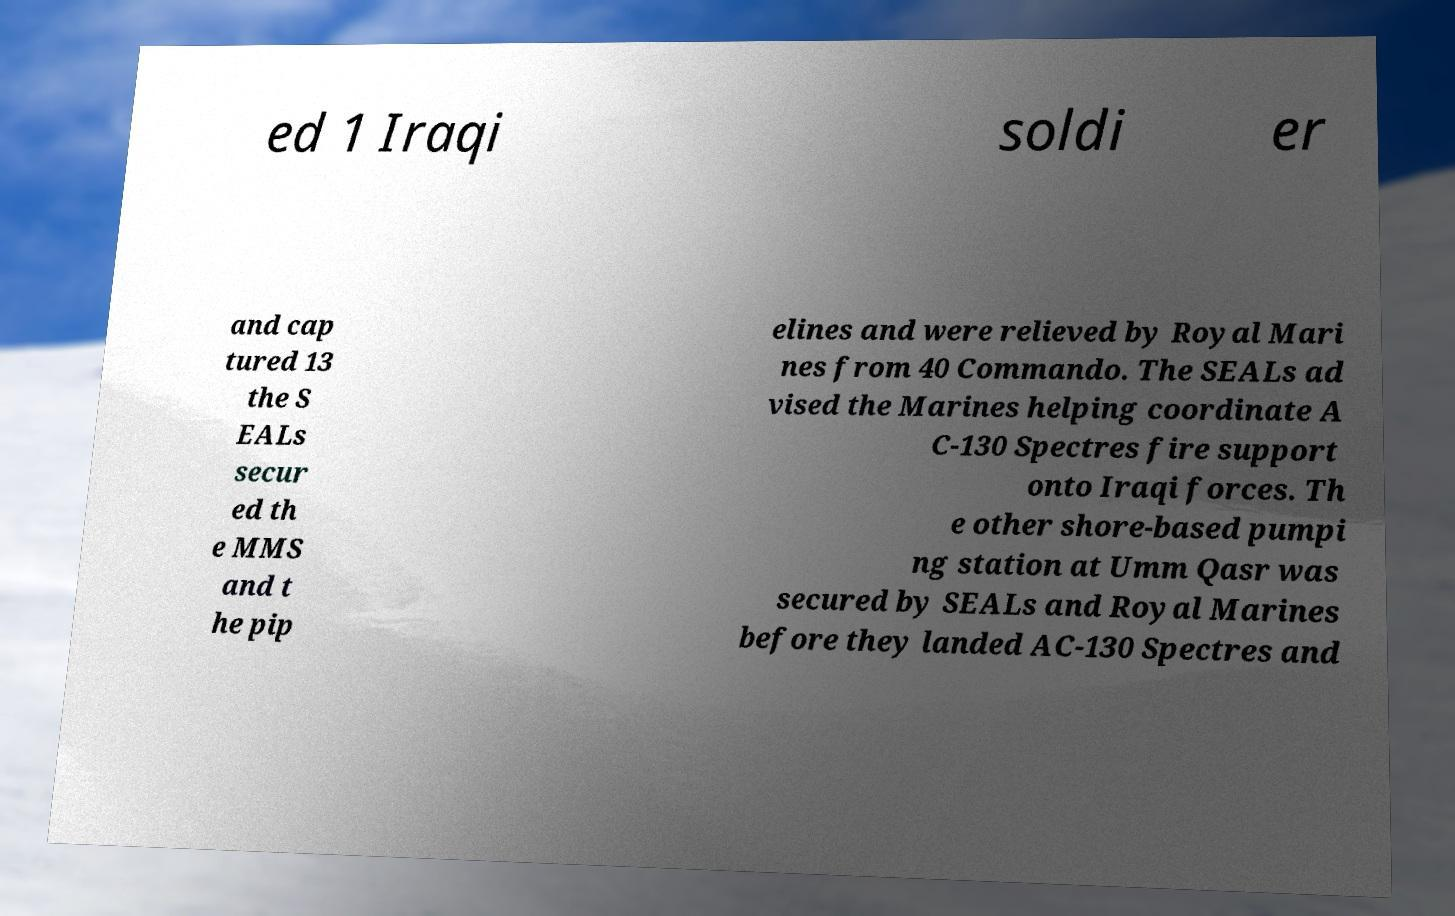Please read and relay the text visible in this image. What does it say? ed 1 Iraqi soldi er and cap tured 13 the S EALs secur ed th e MMS and t he pip elines and were relieved by Royal Mari nes from 40 Commando. The SEALs ad vised the Marines helping coordinate A C-130 Spectres fire support onto Iraqi forces. Th e other shore-based pumpi ng station at Umm Qasr was secured by SEALs and Royal Marines before they landed AC-130 Spectres and 